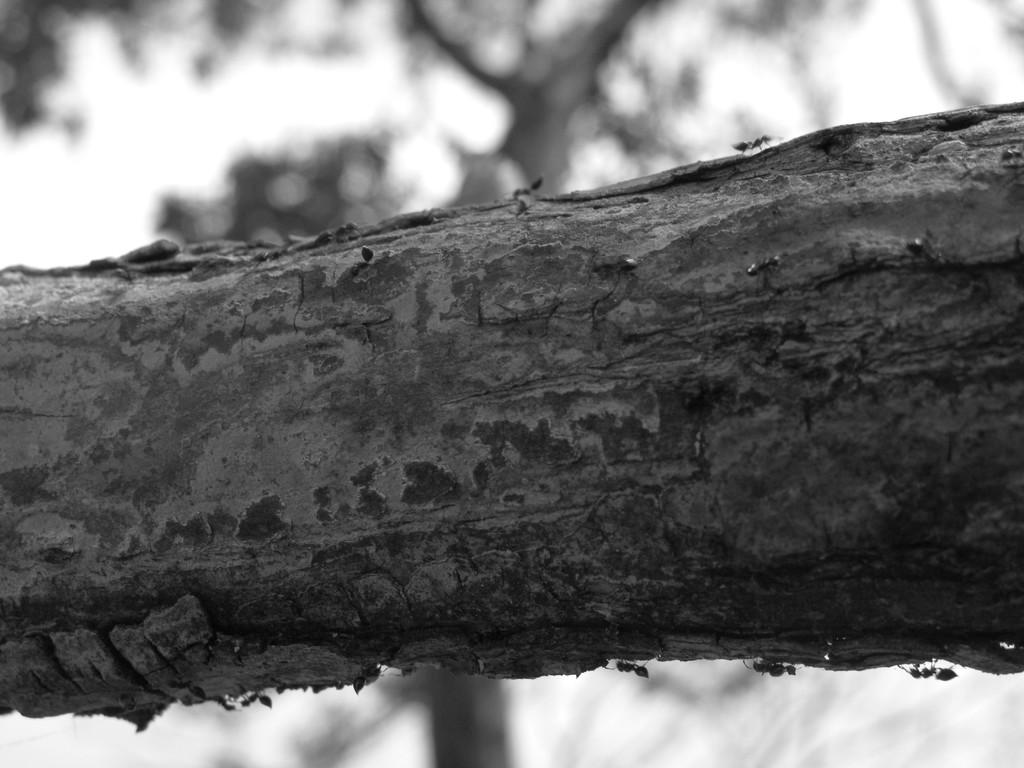What is the color scheme of the image? The image is black and white. What object can be seen in the image? There is a trunk in the image. Can you describe the background of the image? The background of the image is blurred. What type of quilt is draped over the trunk in the image? There is no quilt present in the image; it only features a trunk and a blurred background. How does the bear interact with the trunk in the image? There is no bear present in the image. What does the person in the image regret about their decision to store items in the trunk? There is no person present in the image, and therefore no regret about any decision can be observed. 